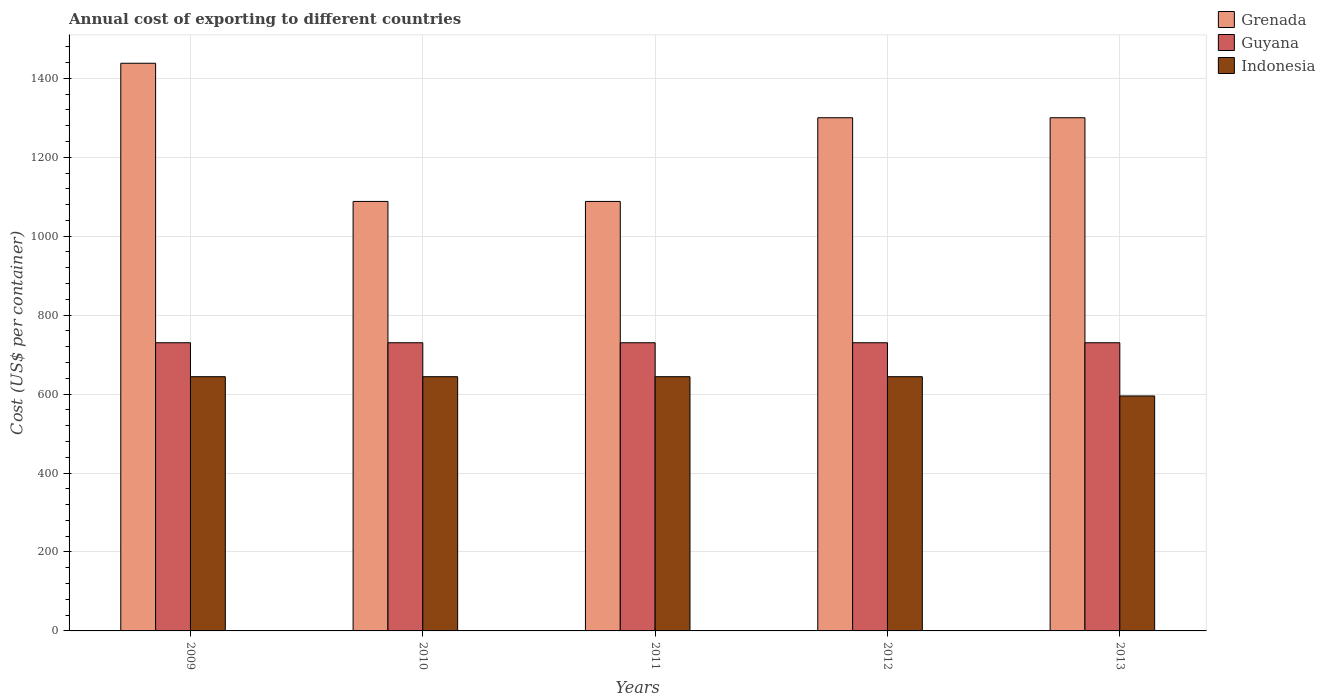How many different coloured bars are there?
Give a very brief answer. 3. Are the number of bars per tick equal to the number of legend labels?
Offer a very short reply. Yes. How many bars are there on the 1st tick from the left?
Keep it short and to the point. 3. How many bars are there on the 2nd tick from the right?
Offer a very short reply. 3. What is the label of the 3rd group of bars from the left?
Keep it short and to the point. 2011. What is the total annual cost of exporting in Indonesia in 2009?
Provide a succinct answer. 644. Across all years, what is the maximum total annual cost of exporting in Indonesia?
Offer a very short reply. 644. Across all years, what is the minimum total annual cost of exporting in Grenada?
Offer a terse response. 1088. In which year was the total annual cost of exporting in Grenada maximum?
Provide a short and direct response. 2009. In which year was the total annual cost of exporting in Grenada minimum?
Give a very brief answer. 2010. What is the total total annual cost of exporting in Grenada in the graph?
Make the answer very short. 6214. What is the difference between the total annual cost of exporting in Grenada in 2012 and the total annual cost of exporting in Guyana in 2013?
Make the answer very short. 570. What is the average total annual cost of exporting in Guyana per year?
Make the answer very short. 730. In the year 2013, what is the difference between the total annual cost of exporting in Indonesia and total annual cost of exporting in Guyana?
Keep it short and to the point. -134.8. What is the ratio of the total annual cost of exporting in Grenada in 2009 to that in 2010?
Your answer should be compact. 1.32. Is the total annual cost of exporting in Grenada in 2010 less than that in 2012?
Your answer should be very brief. Yes. Is the difference between the total annual cost of exporting in Indonesia in 2009 and 2011 greater than the difference between the total annual cost of exporting in Guyana in 2009 and 2011?
Provide a short and direct response. No. What is the difference between the highest and the second highest total annual cost of exporting in Indonesia?
Ensure brevity in your answer.  0. What is the difference between the highest and the lowest total annual cost of exporting in Grenada?
Ensure brevity in your answer.  350. What does the 2nd bar from the left in 2010 represents?
Provide a succinct answer. Guyana. What does the 3rd bar from the right in 2009 represents?
Your answer should be compact. Grenada. Are all the bars in the graph horizontal?
Your answer should be very brief. No. How many years are there in the graph?
Ensure brevity in your answer.  5. What is the difference between two consecutive major ticks on the Y-axis?
Make the answer very short. 200. Does the graph contain grids?
Offer a very short reply. Yes. Where does the legend appear in the graph?
Provide a succinct answer. Top right. How many legend labels are there?
Your answer should be compact. 3. How are the legend labels stacked?
Give a very brief answer. Vertical. What is the title of the graph?
Keep it short and to the point. Annual cost of exporting to different countries. Does "Middle East & North Africa (developing only)" appear as one of the legend labels in the graph?
Provide a succinct answer. No. What is the label or title of the X-axis?
Ensure brevity in your answer.  Years. What is the label or title of the Y-axis?
Offer a very short reply. Cost (US$ per container). What is the Cost (US$ per container) in Grenada in 2009?
Your answer should be compact. 1438. What is the Cost (US$ per container) of Guyana in 2009?
Ensure brevity in your answer.  730. What is the Cost (US$ per container) of Indonesia in 2009?
Make the answer very short. 644. What is the Cost (US$ per container) in Grenada in 2010?
Ensure brevity in your answer.  1088. What is the Cost (US$ per container) in Guyana in 2010?
Make the answer very short. 730. What is the Cost (US$ per container) in Indonesia in 2010?
Offer a very short reply. 644. What is the Cost (US$ per container) in Grenada in 2011?
Keep it short and to the point. 1088. What is the Cost (US$ per container) of Guyana in 2011?
Make the answer very short. 730. What is the Cost (US$ per container) of Indonesia in 2011?
Your answer should be compact. 644. What is the Cost (US$ per container) in Grenada in 2012?
Offer a terse response. 1300. What is the Cost (US$ per container) in Guyana in 2012?
Your answer should be very brief. 730. What is the Cost (US$ per container) in Indonesia in 2012?
Give a very brief answer. 644. What is the Cost (US$ per container) of Grenada in 2013?
Keep it short and to the point. 1300. What is the Cost (US$ per container) of Guyana in 2013?
Your answer should be compact. 730. What is the Cost (US$ per container) in Indonesia in 2013?
Your answer should be very brief. 595.2. Across all years, what is the maximum Cost (US$ per container) in Grenada?
Ensure brevity in your answer.  1438. Across all years, what is the maximum Cost (US$ per container) in Guyana?
Provide a succinct answer. 730. Across all years, what is the maximum Cost (US$ per container) of Indonesia?
Provide a succinct answer. 644. Across all years, what is the minimum Cost (US$ per container) of Grenada?
Keep it short and to the point. 1088. Across all years, what is the minimum Cost (US$ per container) of Guyana?
Provide a short and direct response. 730. Across all years, what is the minimum Cost (US$ per container) of Indonesia?
Give a very brief answer. 595.2. What is the total Cost (US$ per container) in Grenada in the graph?
Provide a short and direct response. 6214. What is the total Cost (US$ per container) of Guyana in the graph?
Your answer should be very brief. 3650. What is the total Cost (US$ per container) in Indonesia in the graph?
Provide a succinct answer. 3171.2. What is the difference between the Cost (US$ per container) in Grenada in 2009 and that in 2010?
Your response must be concise. 350. What is the difference between the Cost (US$ per container) in Grenada in 2009 and that in 2011?
Make the answer very short. 350. What is the difference between the Cost (US$ per container) of Grenada in 2009 and that in 2012?
Give a very brief answer. 138. What is the difference between the Cost (US$ per container) in Guyana in 2009 and that in 2012?
Your answer should be compact. 0. What is the difference between the Cost (US$ per container) of Grenada in 2009 and that in 2013?
Provide a short and direct response. 138. What is the difference between the Cost (US$ per container) in Guyana in 2009 and that in 2013?
Your answer should be very brief. 0. What is the difference between the Cost (US$ per container) in Indonesia in 2009 and that in 2013?
Ensure brevity in your answer.  48.8. What is the difference between the Cost (US$ per container) of Grenada in 2010 and that in 2011?
Keep it short and to the point. 0. What is the difference between the Cost (US$ per container) in Indonesia in 2010 and that in 2011?
Offer a terse response. 0. What is the difference between the Cost (US$ per container) in Grenada in 2010 and that in 2012?
Your response must be concise. -212. What is the difference between the Cost (US$ per container) in Guyana in 2010 and that in 2012?
Ensure brevity in your answer.  0. What is the difference between the Cost (US$ per container) of Indonesia in 2010 and that in 2012?
Give a very brief answer. 0. What is the difference between the Cost (US$ per container) of Grenada in 2010 and that in 2013?
Make the answer very short. -212. What is the difference between the Cost (US$ per container) of Indonesia in 2010 and that in 2013?
Make the answer very short. 48.8. What is the difference between the Cost (US$ per container) in Grenada in 2011 and that in 2012?
Keep it short and to the point. -212. What is the difference between the Cost (US$ per container) in Grenada in 2011 and that in 2013?
Your answer should be compact. -212. What is the difference between the Cost (US$ per container) in Indonesia in 2011 and that in 2013?
Offer a very short reply. 48.8. What is the difference between the Cost (US$ per container) of Indonesia in 2012 and that in 2013?
Give a very brief answer. 48.8. What is the difference between the Cost (US$ per container) in Grenada in 2009 and the Cost (US$ per container) in Guyana in 2010?
Your answer should be very brief. 708. What is the difference between the Cost (US$ per container) of Grenada in 2009 and the Cost (US$ per container) of Indonesia in 2010?
Provide a succinct answer. 794. What is the difference between the Cost (US$ per container) in Guyana in 2009 and the Cost (US$ per container) in Indonesia in 2010?
Your answer should be very brief. 86. What is the difference between the Cost (US$ per container) of Grenada in 2009 and the Cost (US$ per container) of Guyana in 2011?
Ensure brevity in your answer.  708. What is the difference between the Cost (US$ per container) of Grenada in 2009 and the Cost (US$ per container) of Indonesia in 2011?
Ensure brevity in your answer.  794. What is the difference between the Cost (US$ per container) in Guyana in 2009 and the Cost (US$ per container) in Indonesia in 2011?
Offer a very short reply. 86. What is the difference between the Cost (US$ per container) of Grenada in 2009 and the Cost (US$ per container) of Guyana in 2012?
Your answer should be very brief. 708. What is the difference between the Cost (US$ per container) of Grenada in 2009 and the Cost (US$ per container) of Indonesia in 2012?
Offer a terse response. 794. What is the difference between the Cost (US$ per container) in Grenada in 2009 and the Cost (US$ per container) in Guyana in 2013?
Offer a terse response. 708. What is the difference between the Cost (US$ per container) in Grenada in 2009 and the Cost (US$ per container) in Indonesia in 2013?
Keep it short and to the point. 842.8. What is the difference between the Cost (US$ per container) of Guyana in 2009 and the Cost (US$ per container) of Indonesia in 2013?
Offer a very short reply. 134.8. What is the difference between the Cost (US$ per container) of Grenada in 2010 and the Cost (US$ per container) of Guyana in 2011?
Keep it short and to the point. 358. What is the difference between the Cost (US$ per container) in Grenada in 2010 and the Cost (US$ per container) in Indonesia in 2011?
Your answer should be very brief. 444. What is the difference between the Cost (US$ per container) of Grenada in 2010 and the Cost (US$ per container) of Guyana in 2012?
Your response must be concise. 358. What is the difference between the Cost (US$ per container) in Grenada in 2010 and the Cost (US$ per container) in Indonesia in 2012?
Your answer should be compact. 444. What is the difference between the Cost (US$ per container) of Guyana in 2010 and the Cost (US$ per container) of Indonesia in 2012?
Your response must be concise. 86. What is the difference between the Cost (US$ per container) of Grenada in 2010 and the Cost (US$ per container) of Guyana in 2013?
Offer a very short reply. 358. What is the difference between the Cost (US$ per container) of Grenada in 2010 and the Cost (US$ per container) of Indonesia in 2013?
Provide a succinct answer. 492.8. What is the difference between the Cost (US$ per container) of Guyana in 2010 and the Cost (US$ per container) of Indonesia in 2013?
Ensure brevity in your answer.  134.8. What is the difference between the Cost (US$ per container) in Grenada in 2011 and the Cost (US$ per container) in Guyana in 2012?
Ensure brevity in your answer.  358. What is the difference between the Cost (US$ per container) in Grenada in 2011 and the Cost (US$ per container) in Indonesia in 2012?
Offer a terse response. 444. What is the difference between the Cost (US$ per container) of Grenada in 2011 and the Cost (US$ per container) of Guyana in 2013?
Provide a succinct answer. 358. What is the difference between the Cost (US$ per container) of Grenada in 2011 and the Cost (US$ per container) of Indonesia in 2013?
Give a very brief answer. 492.8. What is the difference between the Cost (US$ per container) in Guyana in 2011 and the Cost (US$ per container) in Indonesia in 2013?
Offer a terse response. 134.8. What is the difference between the Cost (US$ per container) in Grenada in 2012 and the Cost (US$ per container) in Guyana in 2013?
Make the answer very short. 570. What is the difference between the Cost (US$ per container) in Grenada in 2012 and the Cost (US$ per container) in Indonesia in 2013?
Offer a terse response. 704.8. What is the difference between the Cost (US$ per container) in Guyana in 2012 and the Cost (US$ per container) in Indonesia in 2013?
Keep it short and to the point. 134.8. What is the average Cost (US$ per container) of Grenada per year?
Ensure brevity in your answer.  1242.8. What is the average Cost (US$ per container) in Guyana per year?
Keep it short and to the point. 730. What is the average Cost (US$ per container) in Indonesia per year?
Your response must be concise. 634.24. In the year 2009, what is the difference between the Cost (US$ per container) of Grenada and Cost (US$ per container) of Guyana?
Offer a very short reply. 708. In the year 2009, what is the difference between the Cost (US$ per container) in Grenada and Cost (US$ per container) in Indonesia?
Your answer should be compact. 794. In the year 2010, what is the difference between the Cost (US$ per container) in Grenada and Cost (US$ per container) in Guyana?
Offer a very short reply. 358. In the year 2010, what is the difference between the Cost (US$ per container) in Grenada and Cost (US$ per container) in Indonesia?
Provide a succinct answer. 444. In the year 2011, what is the difference between the Cost (US$ per container) in Grenada and Cost (US$ per container) in Guyana?
Offer a terse response. 358. In the year 2011, what is the difference between the Cost (US$ per container) in Grenada and Cost (US$ per container) in Indonesia?
Give a very brief answer. 444. In the year 2012, what is the difference between the Cost (US$ per container) of Grenada and Cost (US$ per container) of Guyana?
Give a very brief answer. 570. In the year 2012, what is the difference between the Cost (US$ per container) in Grenada and Cost (US$ per container) in Indonesia?
Provide a short and direct response. 656. In the year 2013, what is the difference between the Cost (US$ per container) of Grenada and Cost (US$ per container) of Guyana?
Provide a succinct answer. 570. In the year 2013, what is the difference between the Cost (US$ per container) in Grenada and Cost (US$ per container) in Indonesia?
Ensure brevity in your answer.  704.8. In the year 2013, what is the difference between the Cost (US$ per container) in Guyana and Cost (US$ per container) in Indonesia?
Provide a succinct answer. 134.8. What is the ratio of the Cost (US$ per container) in Grenada in 2009 to that in 2010?
Give a very brief answer. 1.32. What is the ratio of the Cost (US$ per container) in Indonesia in 2009 to that in 2010?
Offer a very short reply. 1. What is the ratio of the Cost (US$ per container) of Grenada in 2009 to that in 2011?
Keep it short and to the point. 1.32. What is the ratio of the Cost (US$ per container) in Guyana in 2009 to that in 2011?
Ensure brevity in your answer.  1. What is the ratio of the Cost (US$ per container) of Grenada in 2009 to that in 2012?
Offer a terse response. 1.11. What is the ratio of the Cost (US$ per container) in Guyana in 2009 to that in 2012?
Your answer should be very brief. 1. What is the ratio of the Cost (US$ per container) in Grenada in 2009 to that in 2013?
Your answer should be very brief. 1.11. What is the ratio of the Cost (US$ per container) of Indonesia in 2009 to that in 2013?
Provide a succinct answer. 1.08. What is the ratio of the Cost (US$ per container) in Grenada in 2010 to that in 2011?
Ensure brevity in your answer.  1. What is the ratio of the Cost (US$ per container) in Indonesia in 2010 to that in 2011?
Make the answer very short. 1. What is the ratio of the Cost (US$ per container) in Grenada in 2010 to that in 2012?
Keep it short and to the point. 0.84. What is the ratio of the Cost (US$ per container) of Guyana in 2010 to that in 2012?
Your response must be concise. 1. What is the ratio of the Cost (US$ per container) in Indonesia in 2010 to that in 2012?
Your answer should be very brief. 1. What is the ratio of the Cost (US$ per container) of Grenada in 2010 to that in 2013?
Your answer should be compact. 0.84. What is the ratio of the Cost (US$ per container) of Guyana in 2010 to that in 2013?
Ensure brevity in your answer.  1. What is the ratio of the Cost (US$ per container) of Indonesia in 2010 to that in 2013?
Give a very brief answer. 1.08. What is the ratio of the Cost (US$ per container) of Grenada in 2011 to that in 2012?
Your response must be concise. 0.84. What is the ratio of the Cost (US$ per container) of Indonesia in 2011 to that in 2012?
Your response must be concise. 1. What is the ratio of the Cost (US$ per container) in Grenada in 2011 to that in 2013?
Provide a succinct answer. 0.84. What is the ratio of the Cost (US$ per container) in Indonesia in 2011 to that in 2013?
Your answer should be very brief. 1.08. What is the ratio of the Cost (US$ per container) in Guyana in 2012 to that in 2013?
Offer a very short reply. 1. What is the ratio of the Cost (US$ per container) in Indonesia in 2012 to that in 2013?
Offer a terse response. 1.08. What is the difference between the highest and the second highest Cost (US$ per container) of Grenada?
Your answer should be compact. 138. What is the difference between the highest and the lowest Cost (US$ per container) of Grenada?
Make the answer very short. 350. What is the difference between the highest and the lowest Cost (US$ per container) in Guyana?
Your answer should be very brief. 0. What is the difference between the highest and the lowest Cost (US$ per container) of Indonesia?
Your answer should be very brief. 48.8. 